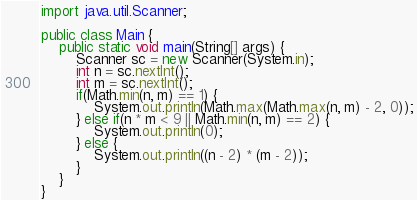Convert code to text. <code><loc_0><loc_0><loc_500><loc_500><_Java_>import java.util.Scanner;

public class Main {
	public static void main(String[] args) {
		Scanner sc = new Scanner(System.in);
		int n = sc.nextInt();
		int m = sc.nextInt();
		if(Math.min(n, m) == 1) {
			System.out.println(Math.max(Math.max(n, m) - 2, 0));
		} else if(n * m < 9 || Math.min(n, m) == 2) {
			System.out.println(0);
		} else {
			System.out.println((n - 2) * (m - 2));
		}
	}
}
</code> 